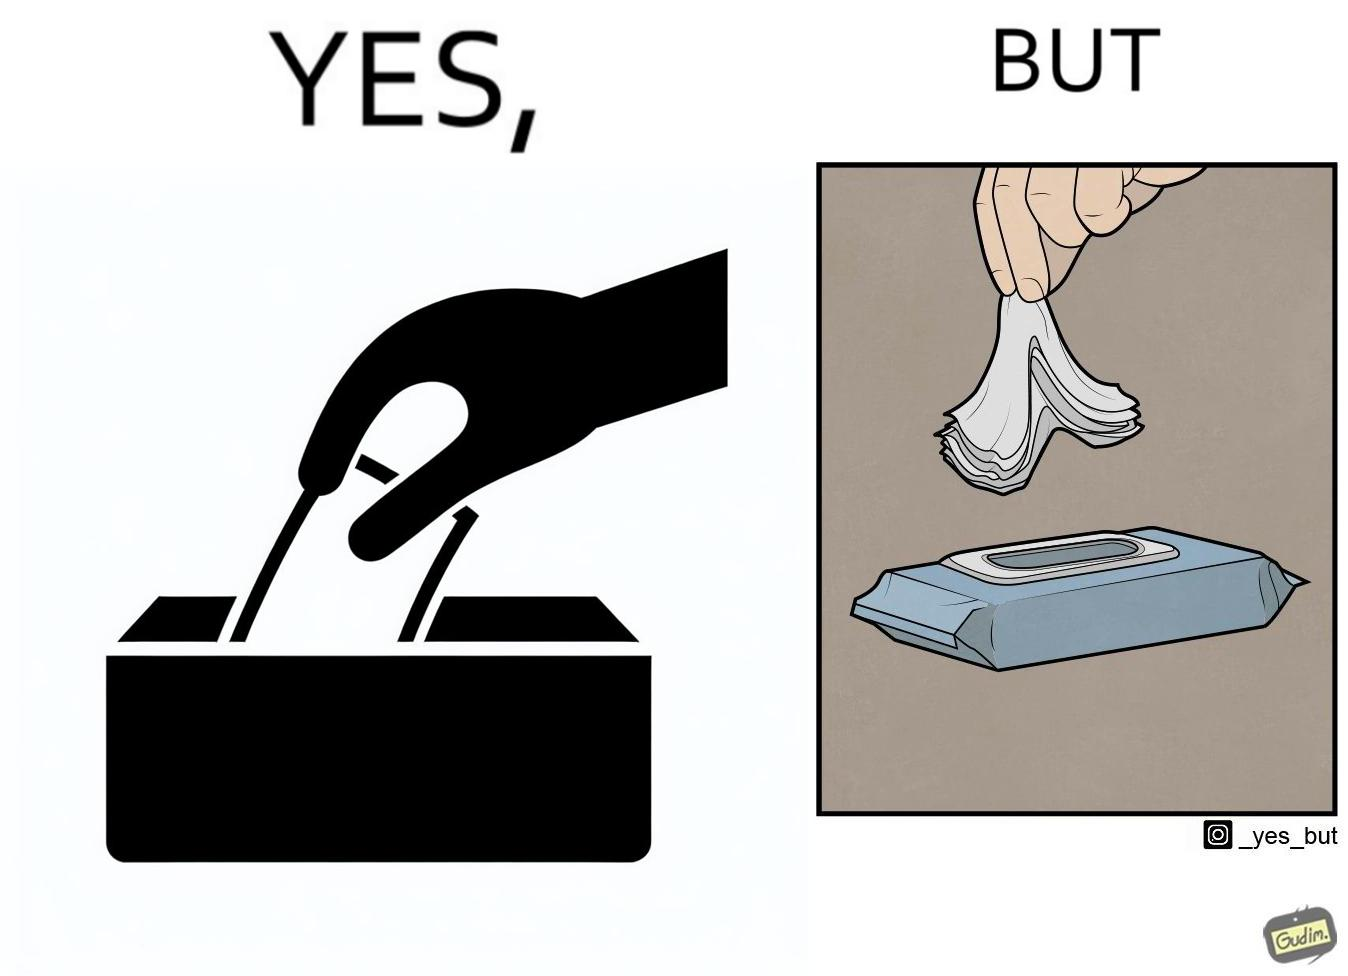Does this image contain satire or humor? Yes, this image is satirical. 